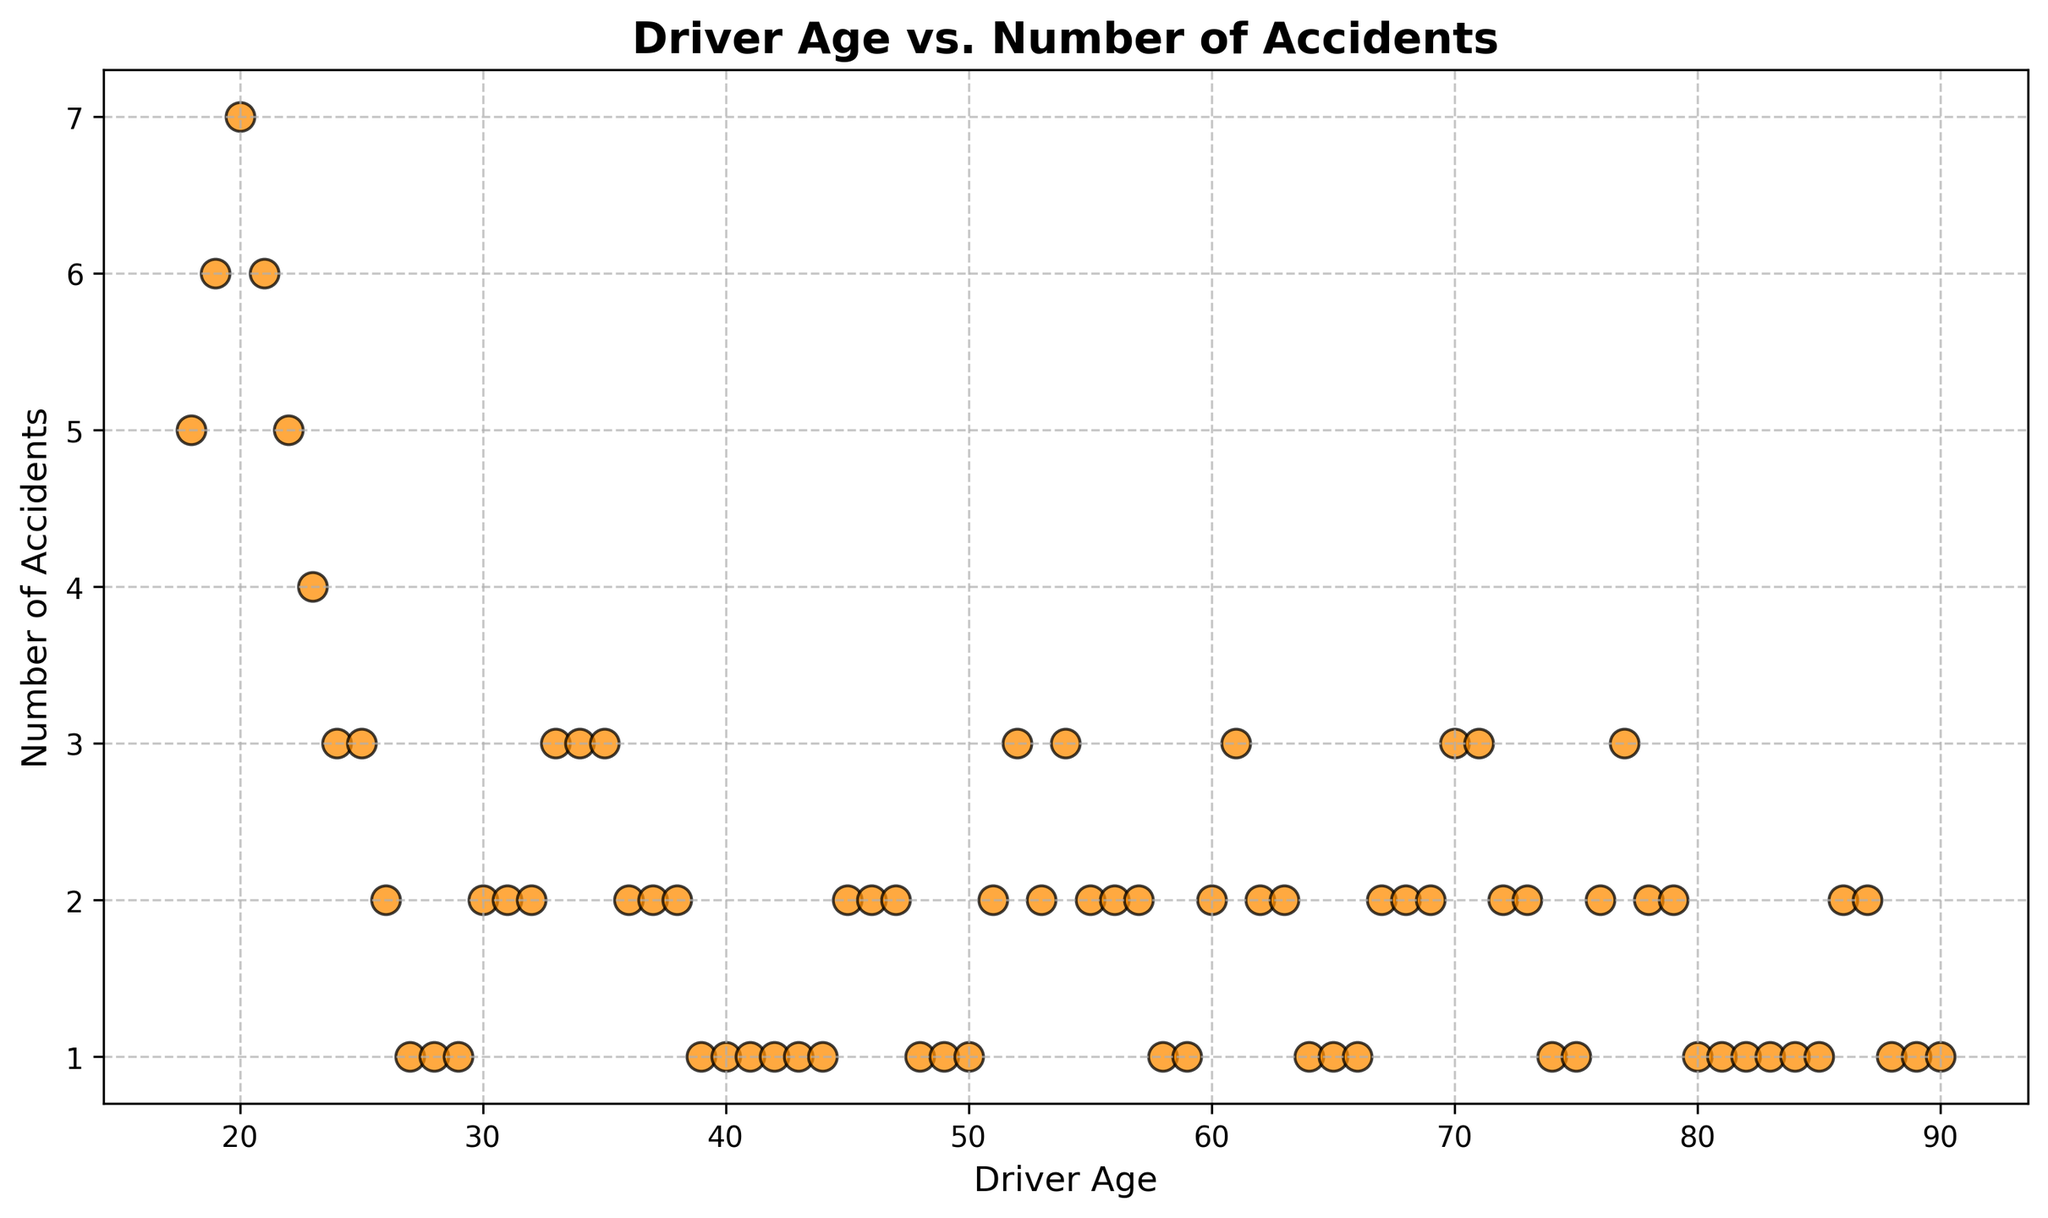What age group has the highest number of accidents? By observing the scattered points, the highest number of accidents is 7, occurring at the age of 20.
Answer: Age 20 What is the trend of the number of accidents as driver age increases from 18 to 25? From ages 18 to 25, the number of accidents generally decreases from 5 accidents at age 18 to 3 accidents at age 25.
Answer: Decreasing Which age group has fewer accidents, drivers in their 20s or drivers in their 50s? By visual comparison, drivers in their 20s (age 20-29) mostly have higher accidents (5-2), whereas drivers in their 50s (age 50-59) have fewer accidents (3-1).
Answer: Drivers in their 50s Are there any age groups where the number of accidents is consistently low? The scattered points show consistently low accidents (between 1-2) for drivers aged 40-50 and 60-90.
Answer: Ages 40-50, 60-90 What is the total number of accidents for drivers aged 30-39? Adding the numbers from ages 30 to 39: 2+2+2+3+3+3+2+2+2+1 = 22 accidents.
Answer: 22 At what age does the number of accidents start to decrease significantly? From age 26 onwards, the number of accidents decreases sharply, dropping from 2 accidents to 1 accident per year.
Answer: Age 26 Which age group has the most variability in the number of accidents? By observing the scatter, drivers aged 18-25 show the most variability, with accidents ranging from 5 to 3.
Answer: Ages 18-25 